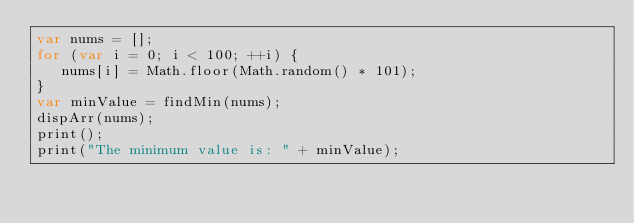Convert code to text. <code><loc_0><loc_0><loc_500><loc_500><_JavaScript_>var nums = [];
for (var i = 0; i < 100; ++i) {
   nums[i] = Math.floor(Math.random() * 101);
}
var minValue = findMin(nums);
dispArr(nums);
print();
print("The minimum value is: " + minValue);</code> 